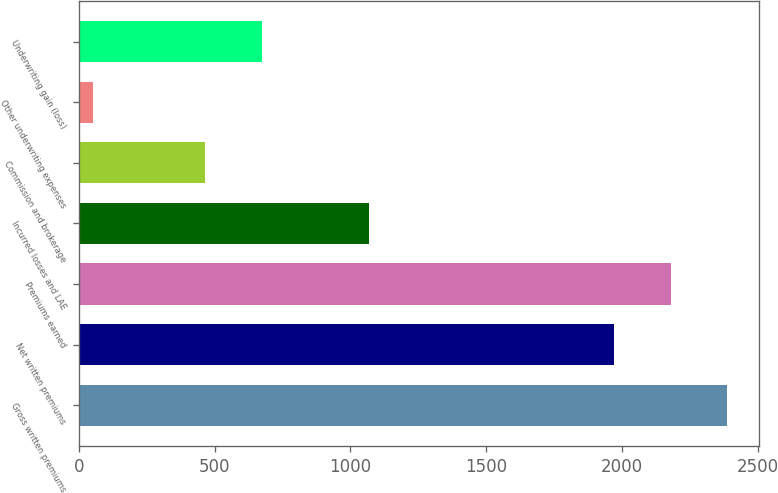<chart> <loc_0><loc_0><loc_500><loc_500><bar_chart><fcel>Gross written premiums<fcel>Net written premiums<fcel>Premiums earned<fcel>Incurred losses and LAE<fcel>Commission and brokerage<fcel>Other underwriting expenses<fcel>Underwriting gain (loss)<nl><fcel>2384.94<fcel>1970.6<fcel>2177.77<fcel>1068.5<fcel>466<fcel>54.1<fcel>673.17<nl></chart> 